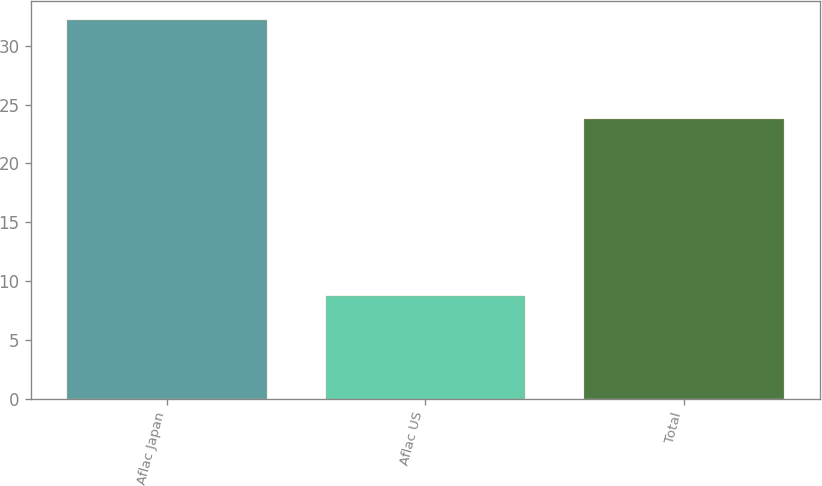Convert chart. <chart><loc_0><loc_0><loc_500><loc_500><bar_chart><fcel>Aflac Japan<fcel>Aflac US<fcel>Total<nl><fcel>32.2<fcel>8.7<fcel>23.8<nl></chart> 